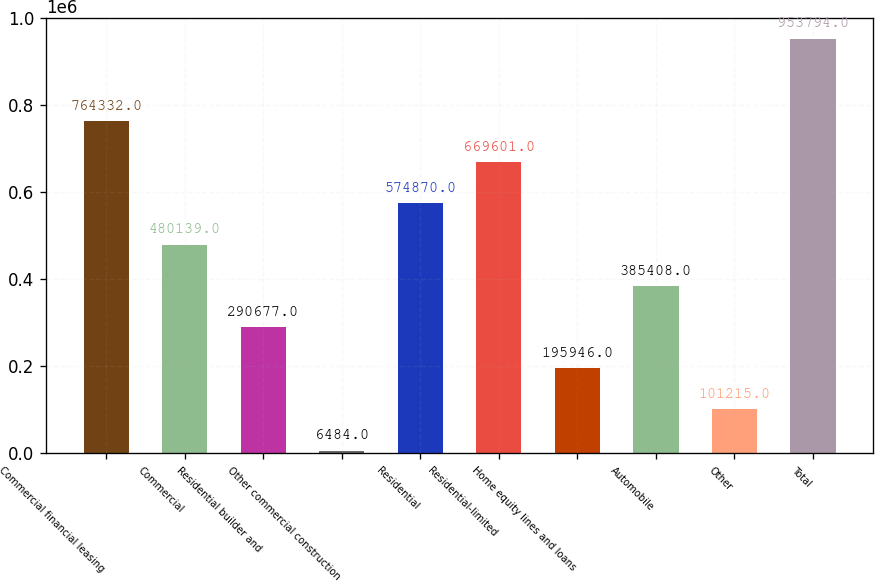Convert chart. <chart><loc_0><loc_0><loc_500><loc_500><bar_chart><fcel>Commercial financial leasing<fcel>Commercial<fcel>Residential builder and<fcel>Other commercial construction<fcel>Residential<fcel>Residential-limited<fcel>Home equity lines and loans<fcel>Automobile<fcel>Other<fcel>Total<nl><fcel>764332<fcel>480139<fcel>290677<fcel>6484<fcel>574870<fcel>669601<fcel>195946<fcel>385408<fcel>101215<fcel>953794<nl></chart> 